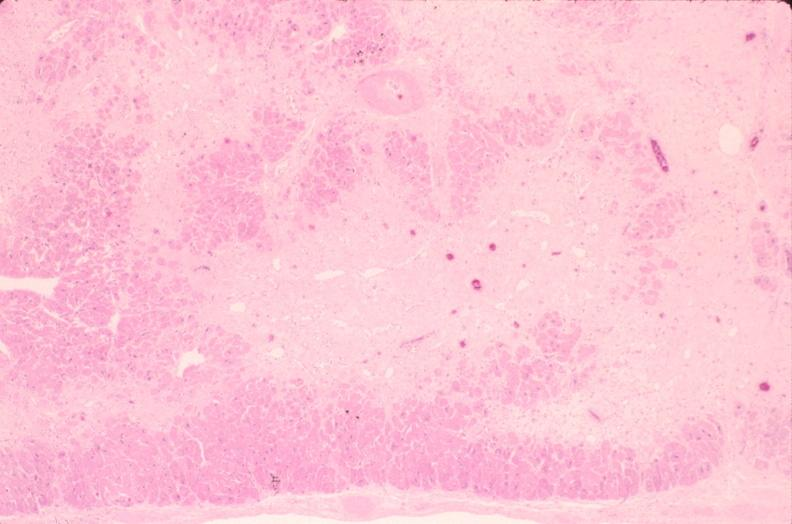s situs inversus present?
Answer the question using a single word or phrase. No 